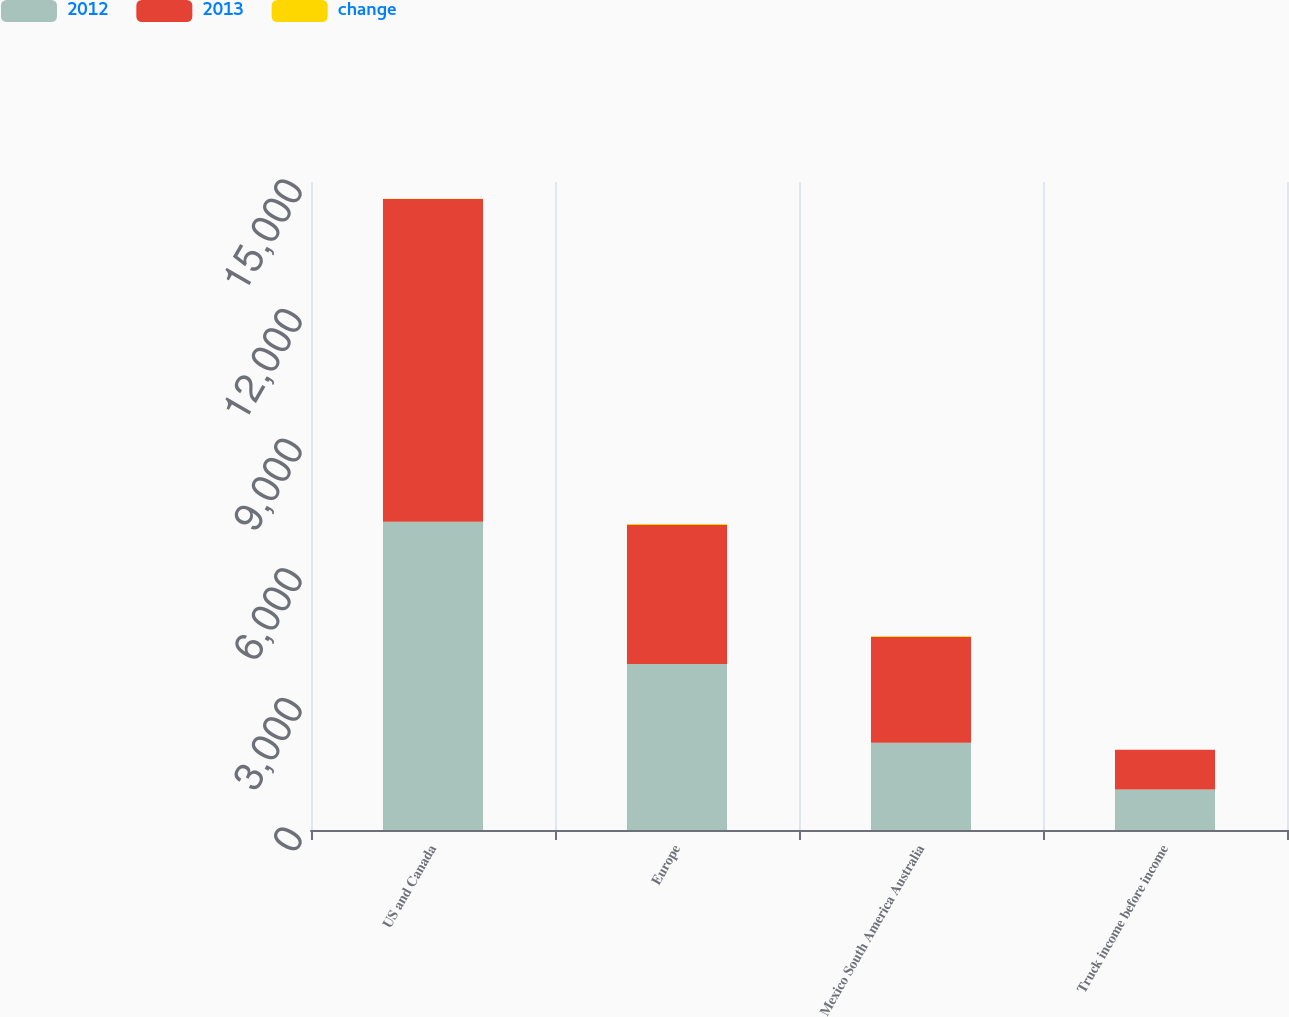Convert chart to OTSL. <chart><loc_0><loc_0><loc_500><loc_500><stacked_bar_chart><ecel><fcel>US and Canada<fcel>Europe<fcel>Mexico South America Australia<fcel>Truck income before income<nl><fcel>2012<fcel>7138.1<fcel>3844.4<fcel>2020.4<fcel>936.7<nl><fcel>2013<fcel>7467.8<fcel>3217.1<fcel>2446.6<fcel>920.4<nl><fcel>change<fcel>4<fcel>19<fcel>17<fcel>2<nl></chart> 